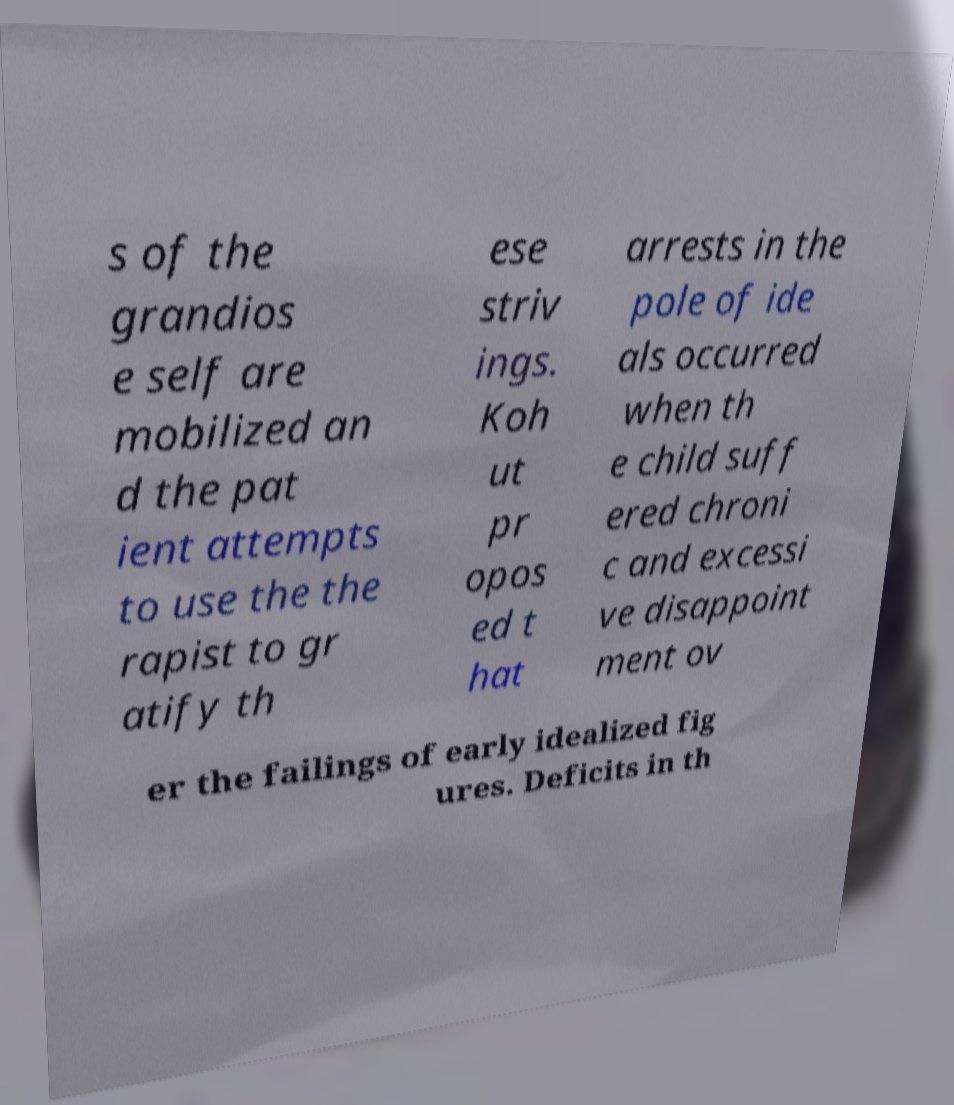Could you extract and type out the text from this image? s of the grandios e self are mobilized an d the pat ient attempts to use the the rapist to gr atify th ese striv ings. Koh ut pr opos ed t hat arrests in the pole of ide als occurred when th e child suff ered chroni c and excessi ve disappoint ment ov er the failings of early idealized fig ures. Deficits in th 